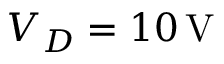Convert formula to latex. <formula><loc_0><loc_0><loc_500><loc_500>V _ { D } = 1 0 \, V</formula> 